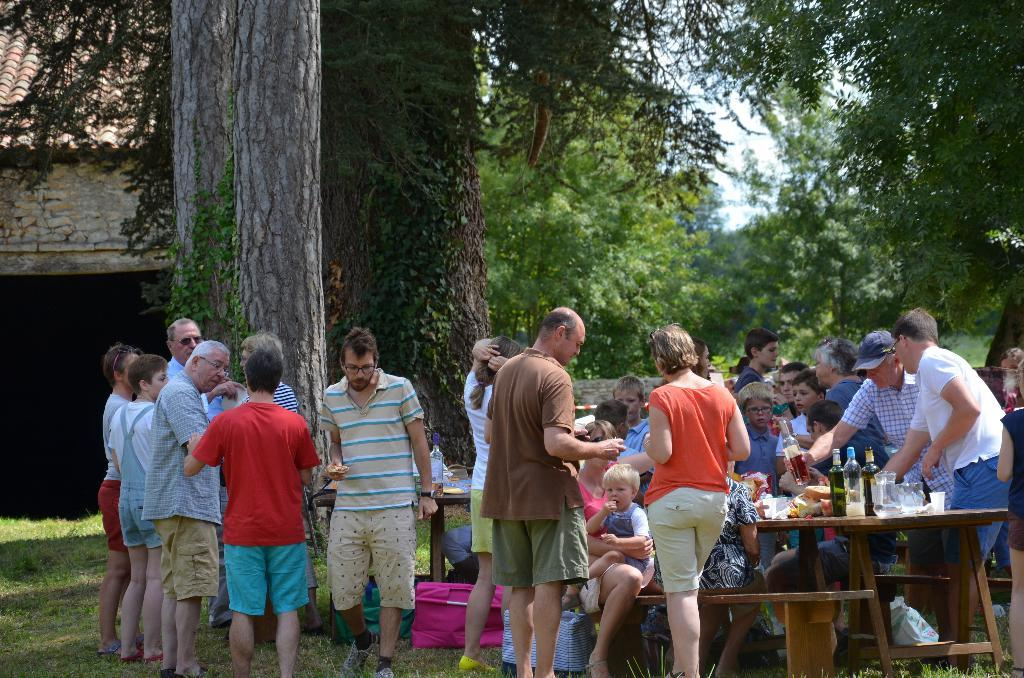What are the people in the image doing? There are people standing and sitting on a bench in the image. What is on the table in the image? Wine bottles and food items are on the table in the image. What can be seen in the background of the image? There is a house, trees, and the sky visible in the background of the image. What type of string can be seen connecting the people in the image? There is no string connecting the people in the image. What does the flesh of the people in the image taste like? The image does not provide any information about the taste of the people's flesh, as it is not relevant to the image's content. 